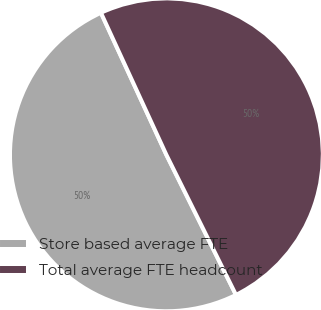Convert chart. <chart><loc_0><loc_0><loc_500><loc_500><pie_chart><fcel>Store based average FTE<fcel>Total average FTE headcount<nl><fcel>50.47%<fcel>49.53%<nl></chart> 